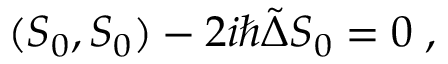Convert formula to latex. <formula><loc_0><loc_0><loc_500><loc_500>( S _ { 0 } , S _ { 0 } ) - 2 i \hbar { \tilde } { \Delta } S _ { 0 } = 0 \, ,</formula> 